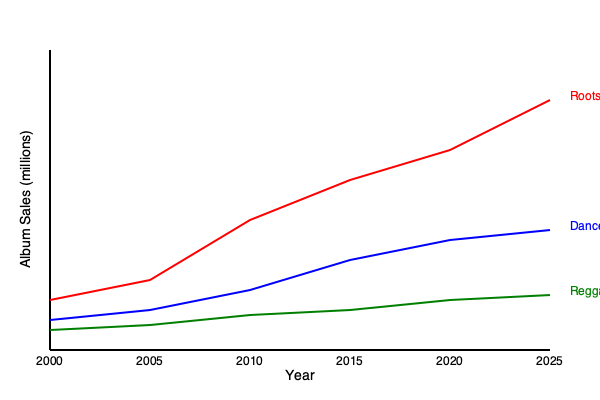Based on the line graph showing album sales trends of different reggae subgenres from 2000 to 2025, which subgenre demonstrates the most significant growth in popularity, and what factors might contribute to this trend? To answer this question, we need to analyze the trends for each subgenre:

1. Roots Reggae (red line):
   - Starts around 5 million sales in 2000
   - Shows steady growth throughout the period
   - Reaches about 25 million sales by 2025
   - Total growth: approximately 20 million sales

2. Dancehall (blue line):
   - Starts around 3 million sales in 2000
   - Shows moderate growth
   - Reaches about 12 million sales by 2025
   - Total growth: approximately 9 million sales

3. Reggaeton (green line):
   - Starts around 2 million sales in 2000
   - Shows slow but steady growth
   - Reaches about 5.5 million sales by 2025
   - Total growth: approximately 3.5 million sales

Roots Reggae demonstrates the most significant growth in popularity, with the steepest upward trend and the largest increase in sales over the period.

Factors contributing to this trend may include:
1. Growing global appreciation for traditional reggae sounds
2. Increased exposure through streaming platforms and international festivals
3. Revival of interest in classic reggae artists and their music
4. Crossover appeal with other genres, attracting a wider audience
5. Cultural shifts favoring conscious and socially aware music

The steady growth of Roots Reggae suggests a lasting appeal and potential for continued expansion in the global music market.
Answer: Roots Reggae, due to its steepest growth curve and largest sales increase. 